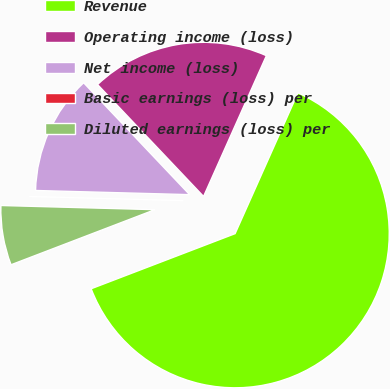Convert chart. <chart><loc_0><loc_0><loc_500><loc_500><pie_chart><fcel>Revenue<fcel>Operating income (loss)<fcel>Net income (loss)<fcel>Basic earnings (loss) per<fcel>Diluted earnings (loss) per<nl><fcel>62.5%<fcel>18.75%<fcel>12.5%<fcel>0.0%<fcel>6.25%<nl></chart> 